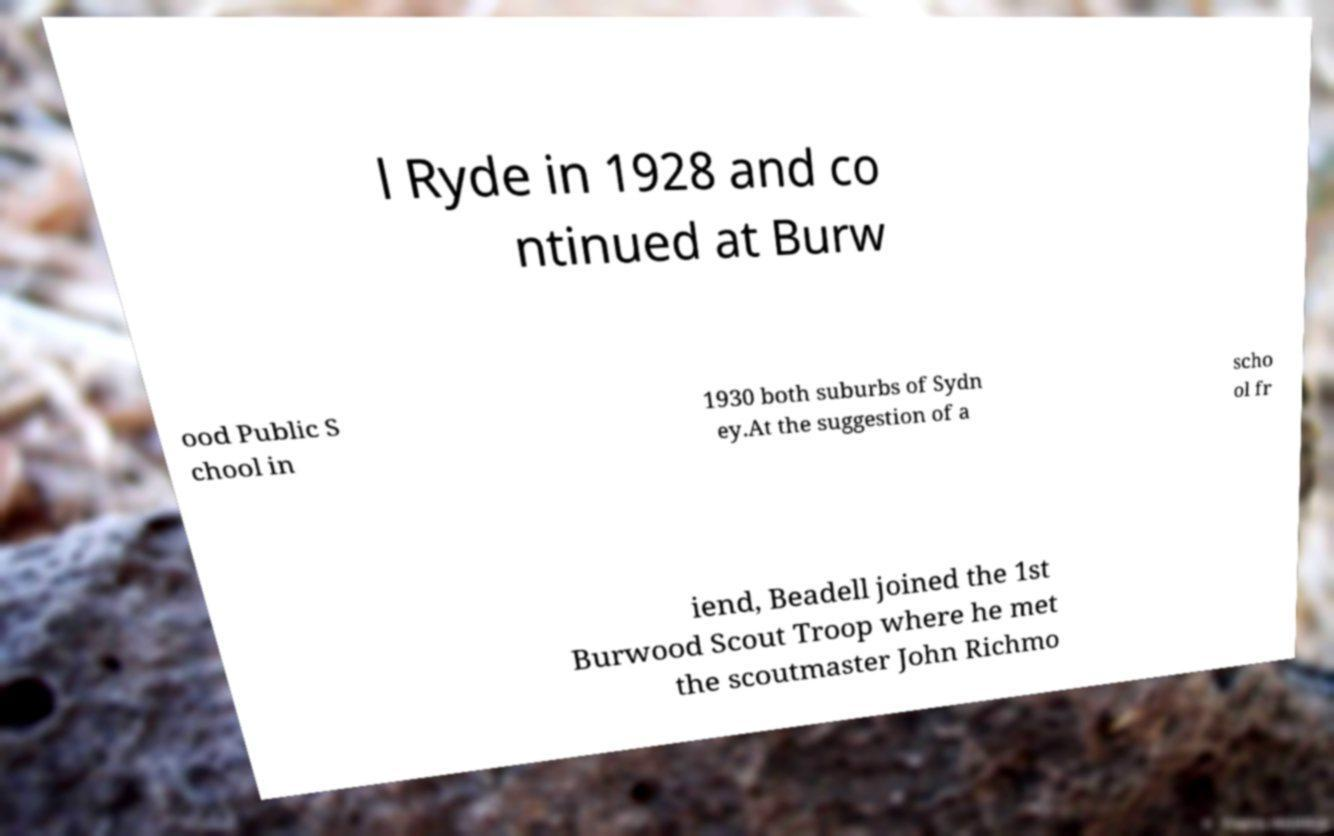Please read and relay the text visible in this image. What does it say? l Ryde in 1928 and co ntinued at Burw ood Public S chool in 1930 both suburbs of Sydn ey.At the suggestion of a scho ol fr iend, Beadell joined the 1st Burwood Scout Troop where he met the scoutmaster John Richmo 